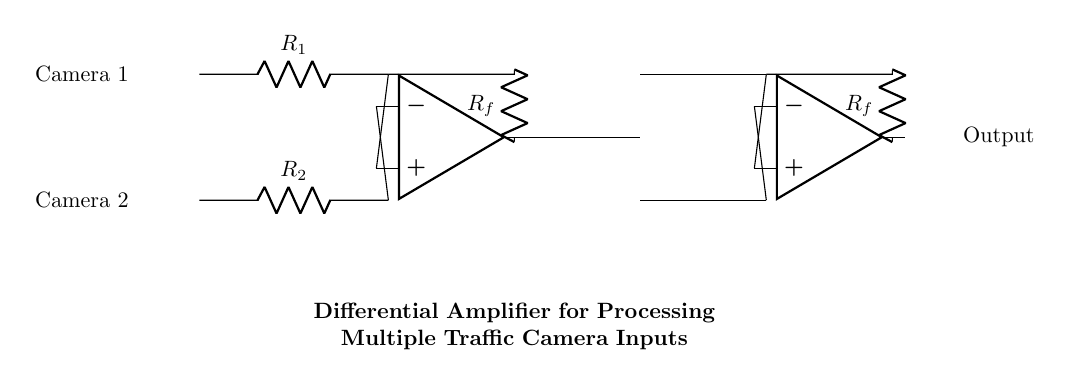What are the input components used in the circuit? The circuit uses two input resistors labeled R1 and R2, which are connected to the inputs from Camera 1 and Camera 2 respectively.
Answer: R1 and R2 What is the function of the operational amplifiers in this circuit? The operational amplifiers in this circuit amplify the difference between the voltages from the two inputs, optimizing the processing of multiple camera signals.
Answer: Amplification What do the feedback resistors Rf do in this circuit? The feedback resistors Rf are used to set the gain of the differential amplifiers, determining how much the output is amplified based on the input difference.
Answer: Gain control How many traffic camera inputs can this circuit simultaneously process? The circuit is designed to process inputs from two traffic cameras: Camera 1 and Camera 2, which are connected to the two separate inputs of the differential amplifier.
Answer: Two What type of amplifier is presented in this circuit diagram? This circuit diagram represents a differential amplifier specifically designed to work with multiple inputs, providing a difference in voltage as output based on two separate camera feeds.
Answer: Differential amplifier What is the output of this circuit? The output is the amplified difference between the voltages received from the two traffic cameras, enabling clearer signal processing for traffic direction purposes.
Answer: Output 